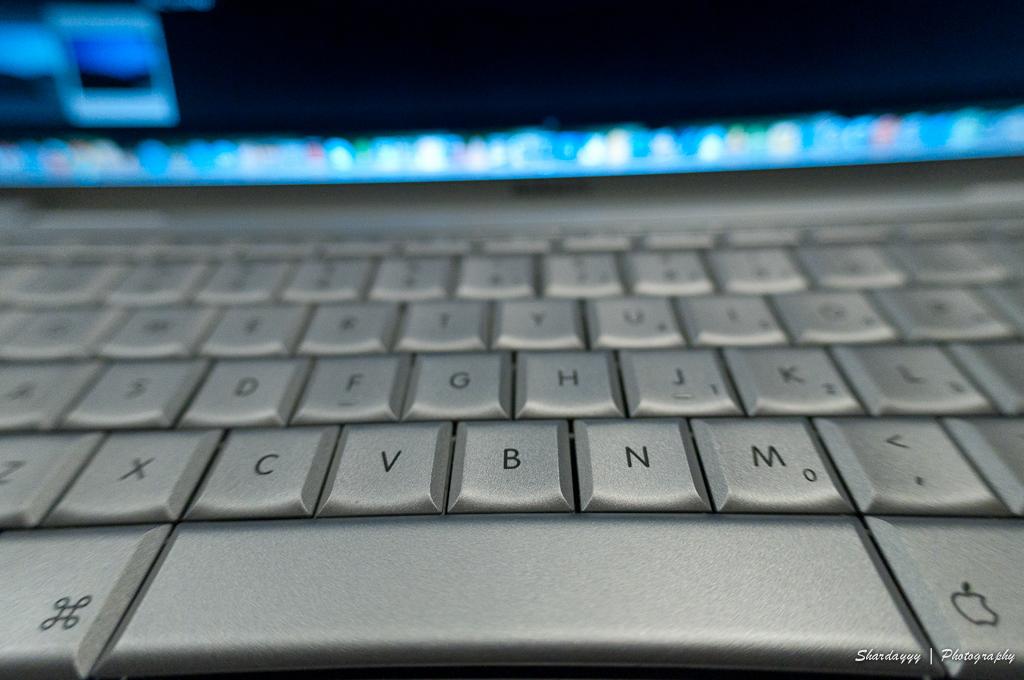What are the letters of the bottom row?
Ensure brevity in your answer.  Zxcvbnm. 